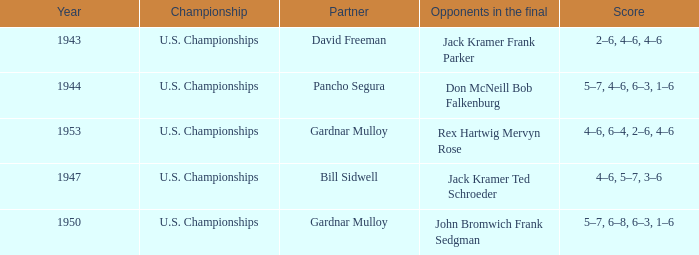Which Partner has Opponents in the final of john bromwich frank sedgman? Gardnar Mulloy. 